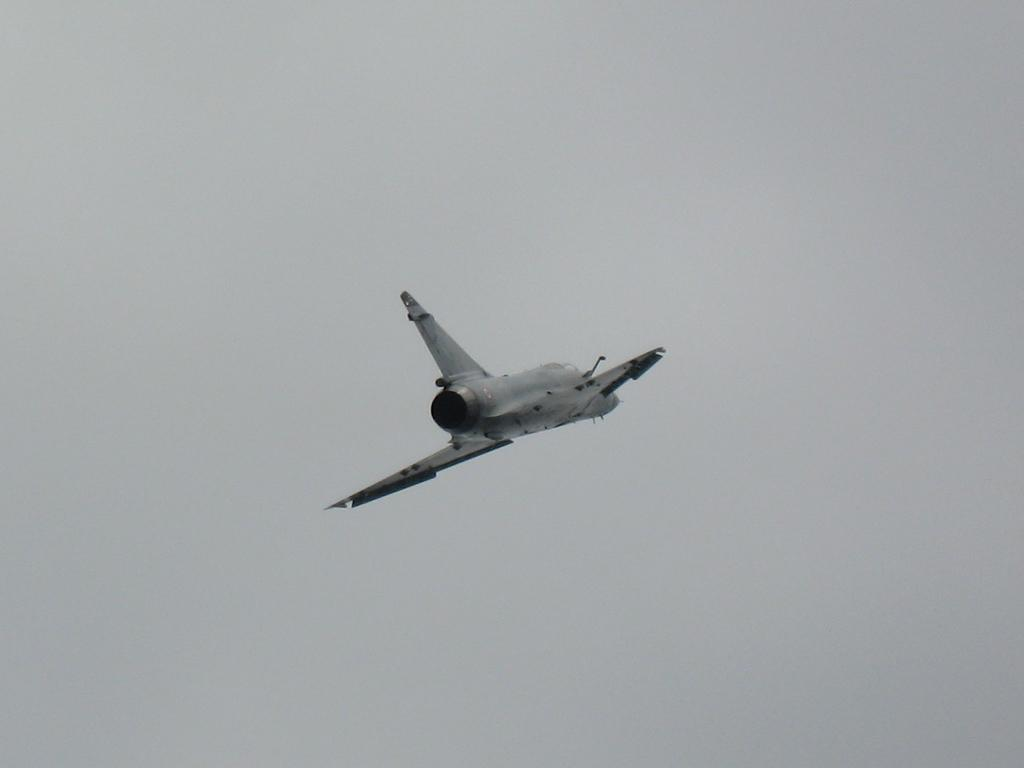What is the main subject in the center of the image? There is a spacecraft in the air in the center of the image. What can be seen in the background of the image? The sky is visible in the background of the image. What is the spacecraft's digestion process like in the image? The spacecraft does not have a digestion process, as it is a vehicle and not a living organism. 